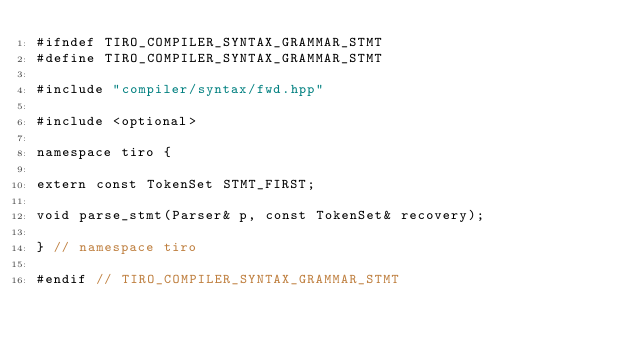Convert code to text. <code><loc_0><loc_0><loc_500><loc_500><_C++_>#ifndef TIRO_COMPILER_SYNTAX_GRAMMAR_STMT
#define TIRO_COMPILER_SYNTAX_GRAMMAR_STMT

#include "compiler/syntax/fwd.hpp"

#include <optional>

namespace tiro {

extern const TokenSet STMT_FIRST;

void parse_stmt(Parser& p, const TokenSet& recovery);

} // namespace tiro

#endif // TIRO_COMPILER_SYNTAX_GRAMMAR_STMT
</code> 